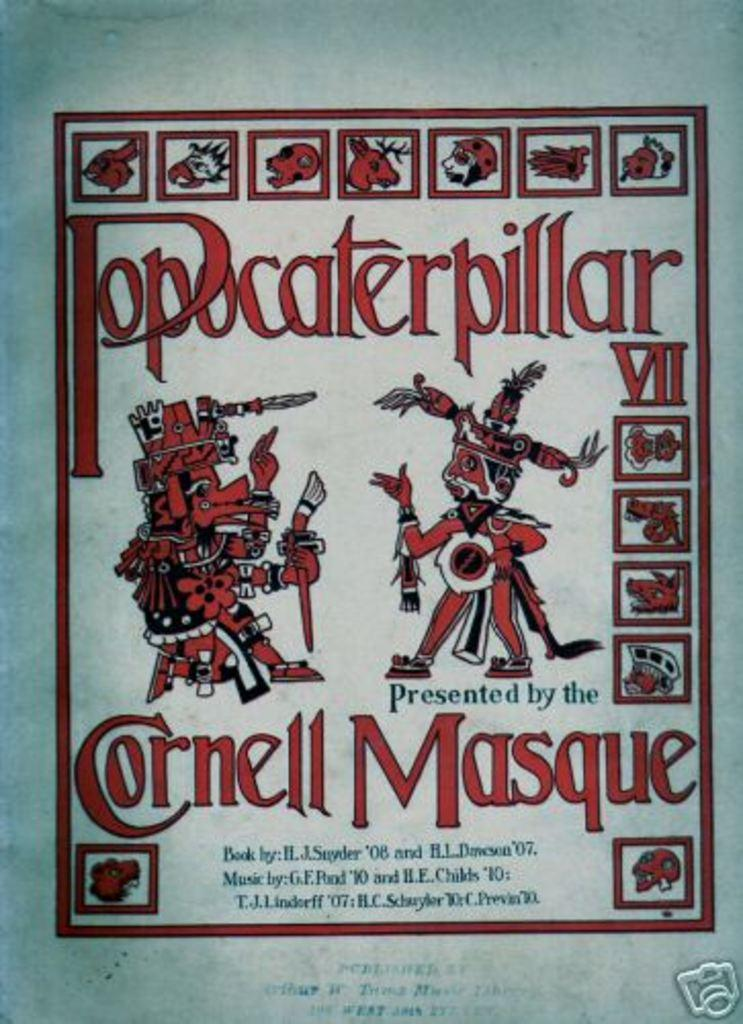<image>
Summarize the visual content of the image. a red painting with the word Cornell under it 